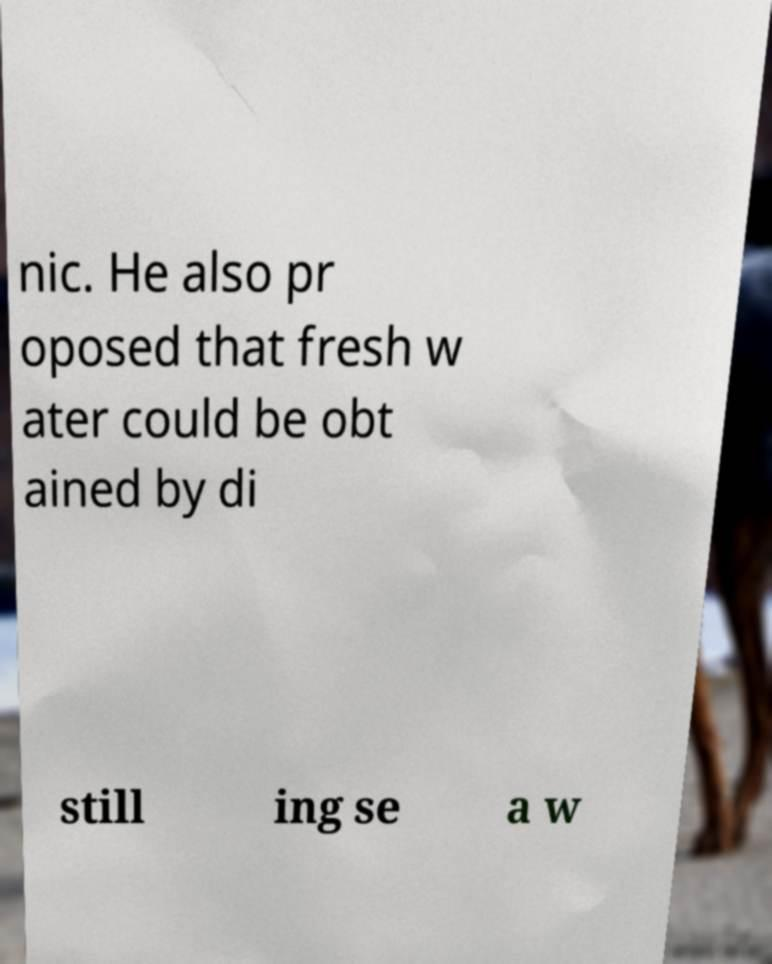Can you accurately transcribe the text from the provided image for me? nic. He also pr oposed that fresh w ater could be obt ained by di still ing se a w 